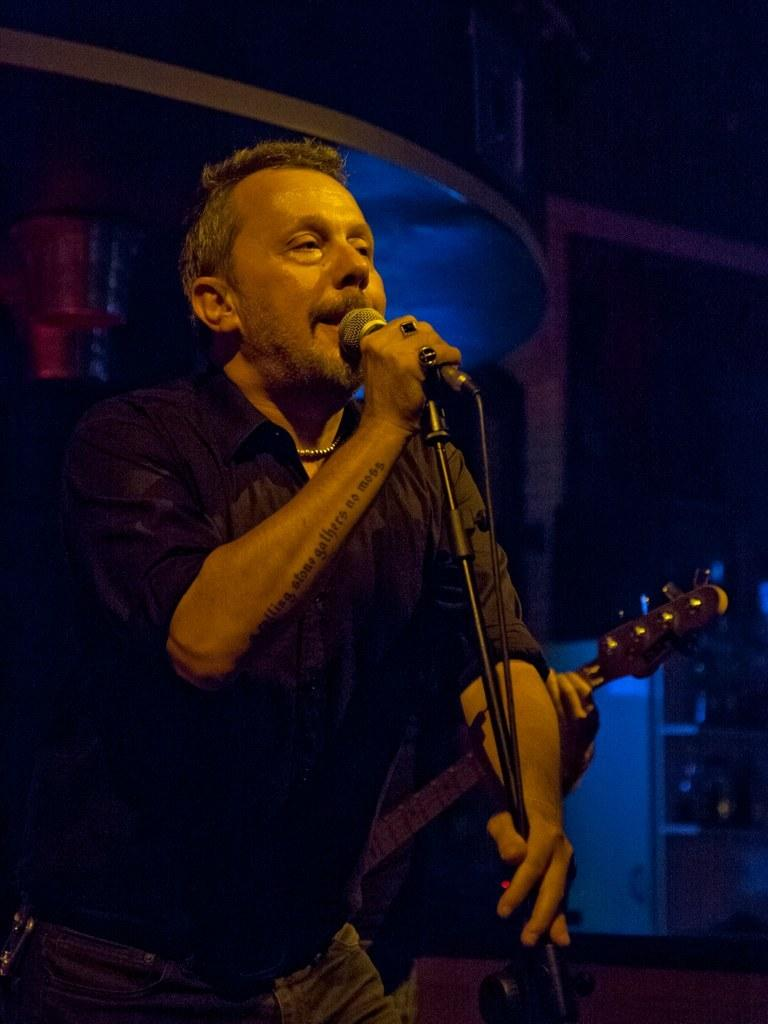What type of event is the image from? The image is from a musical concert. Can you describe the person in the image? There is a man in the image, and he is wearing a black shirt. What is the man holding in the image? The man is holding a microphone. What is the man doing in the image? The man is singing. How is the environment in the image? The image is taken in a dark environment. What is the title of the argument the man is having with the audience in the image? There is no argument present in the image; the man is singing. What type of crush does the man have on the woman in the image? There is no woman or any indication of a crush in the image; it only features a man singing. 